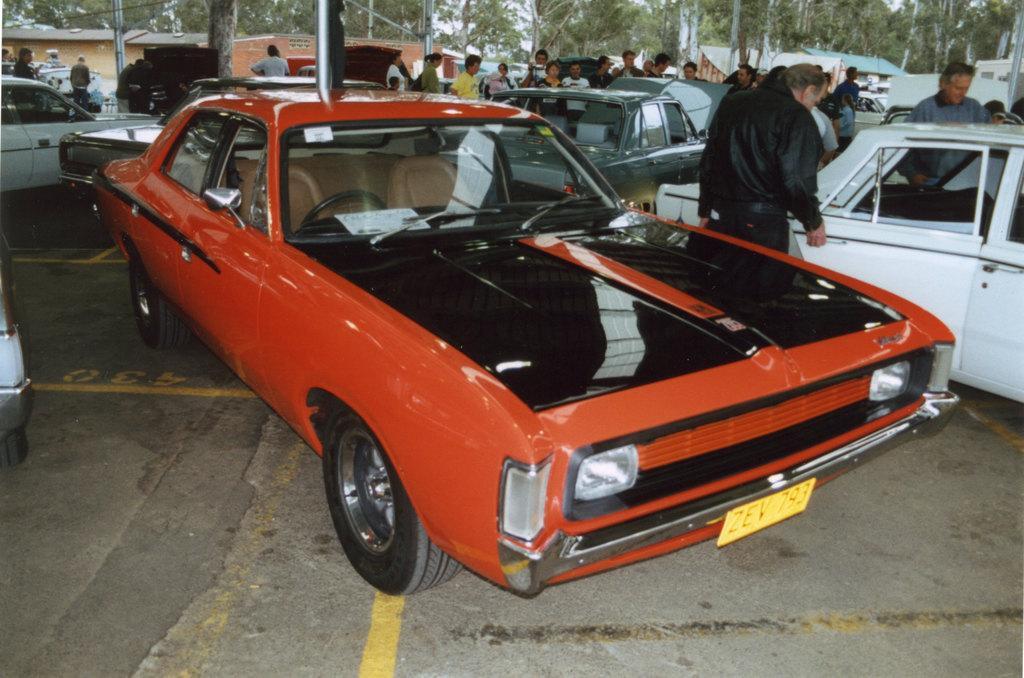In one or two sentences, can you explain what this image depicts? In this picture we can see a few vehicles on the path. There are some people, houses and trees in the background. 